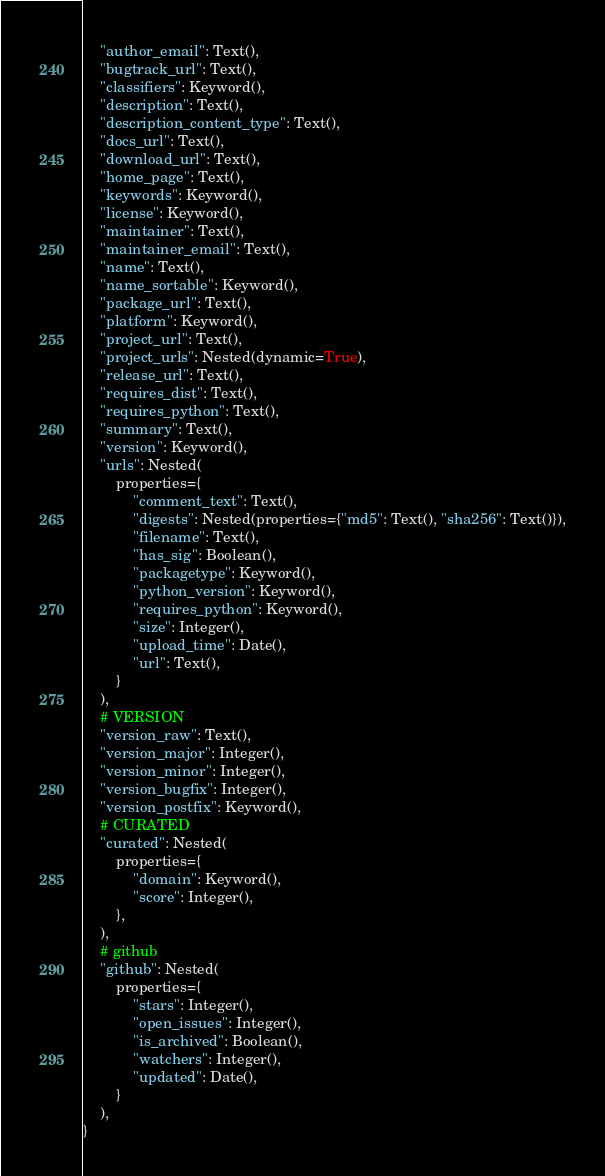<code> <loc_0><loc_0><loc_500><loc_500><_Python_>    "author_email": Text(),
    "bugtrack_url": Text(),
    "classifiers": Keyword(),
    "description": Text(),
    "description_content_type": Text(),
    "docs_url": Text(),
    "download_url": Text(),
    "home_page": Text(),
    "keywords": Keyword(),
    "license": Keyword(),
    "maintainer": Text(),
    "maintainer_email": Text(),
    "name": Text(),
    "name_sortable": Keyword(),
    "package_url": Text(),
    "platform": Keyword(),
    "project_url": Text(),
    "project_urls": Nested(dynamic=True),
    "release_url": Text(),
    "requires_dist": Text(),
    "requires_python": Text(),
    "summary": Text(),
    "version": Keyword(),
    "urls": Nested(
        properties={
            "comment_text": Text(),
            "digests": Nested(properties={"md5": Text(), "sha256": Text()}),
            "filename": Text(),
            "has_sig": Boolean(),
            "packagetype": Keyword(),
            "python_version": Keyword(),
            "requires_python": Keyword(),
            "size": Integer(),
            "upload_time": Date(),
            "url": Text(),
        }
    ),
    # VERSION
    "version_raw": Text(),
    "version_major": Integer(),
    "version_minor": Integer(),
    "version_bugfix": Integer(),
    "version_postfix": Keyword(),
    # CURATED
    "curated": Nested(
        properties={
            "domain": Keyword(),
            "score": Integer(),
        },
    ),
    # github
    "github": Nested(
        properties={
            "stars": Integer(),
            "open_issues": Integer(),
            "is_archived": Boolean(),
            "watchers": Integer(),
            "updated": Date(),
        }
    ),
}
</code> 